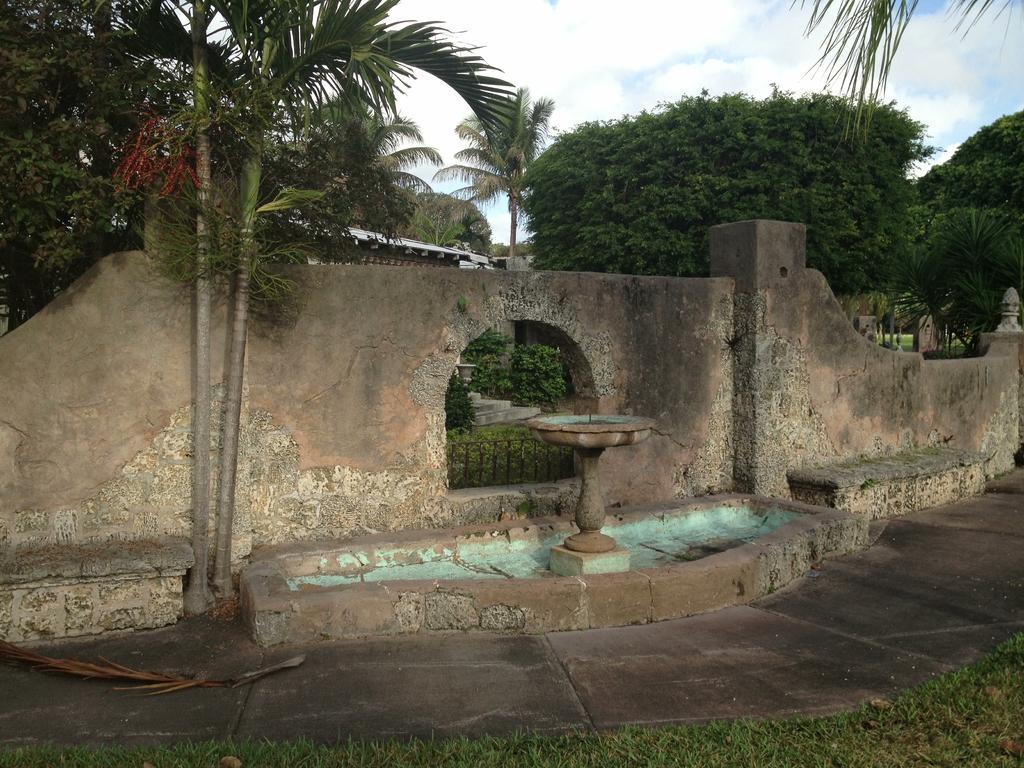Please provide a concise description of this image. In this picture I can observe wall in the middle of the picture. In the background there are trees and some clouds in the sky. 